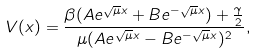Convert formula to latex. <formula><loc_0><loc_0><loc_500><loc_500>V ( x ) = \frac { \beta ( A e ^ { \sqrt { \mu } x } + B e ^ { - \sqrt { \mu } x } ) + \frac { \gamma } { 2 } } { \mu ( A e ^ { \sqrt { \mu } x } - B e ^ { - \sqrt { \mu } x } ) ^ { 2 } } ,</formula> 